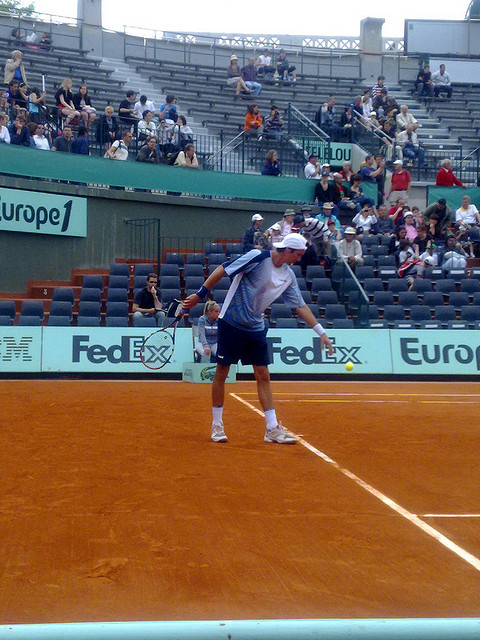Please identify all text content in this image. urope1 VELBLOU FedEx FedEx M Euro 